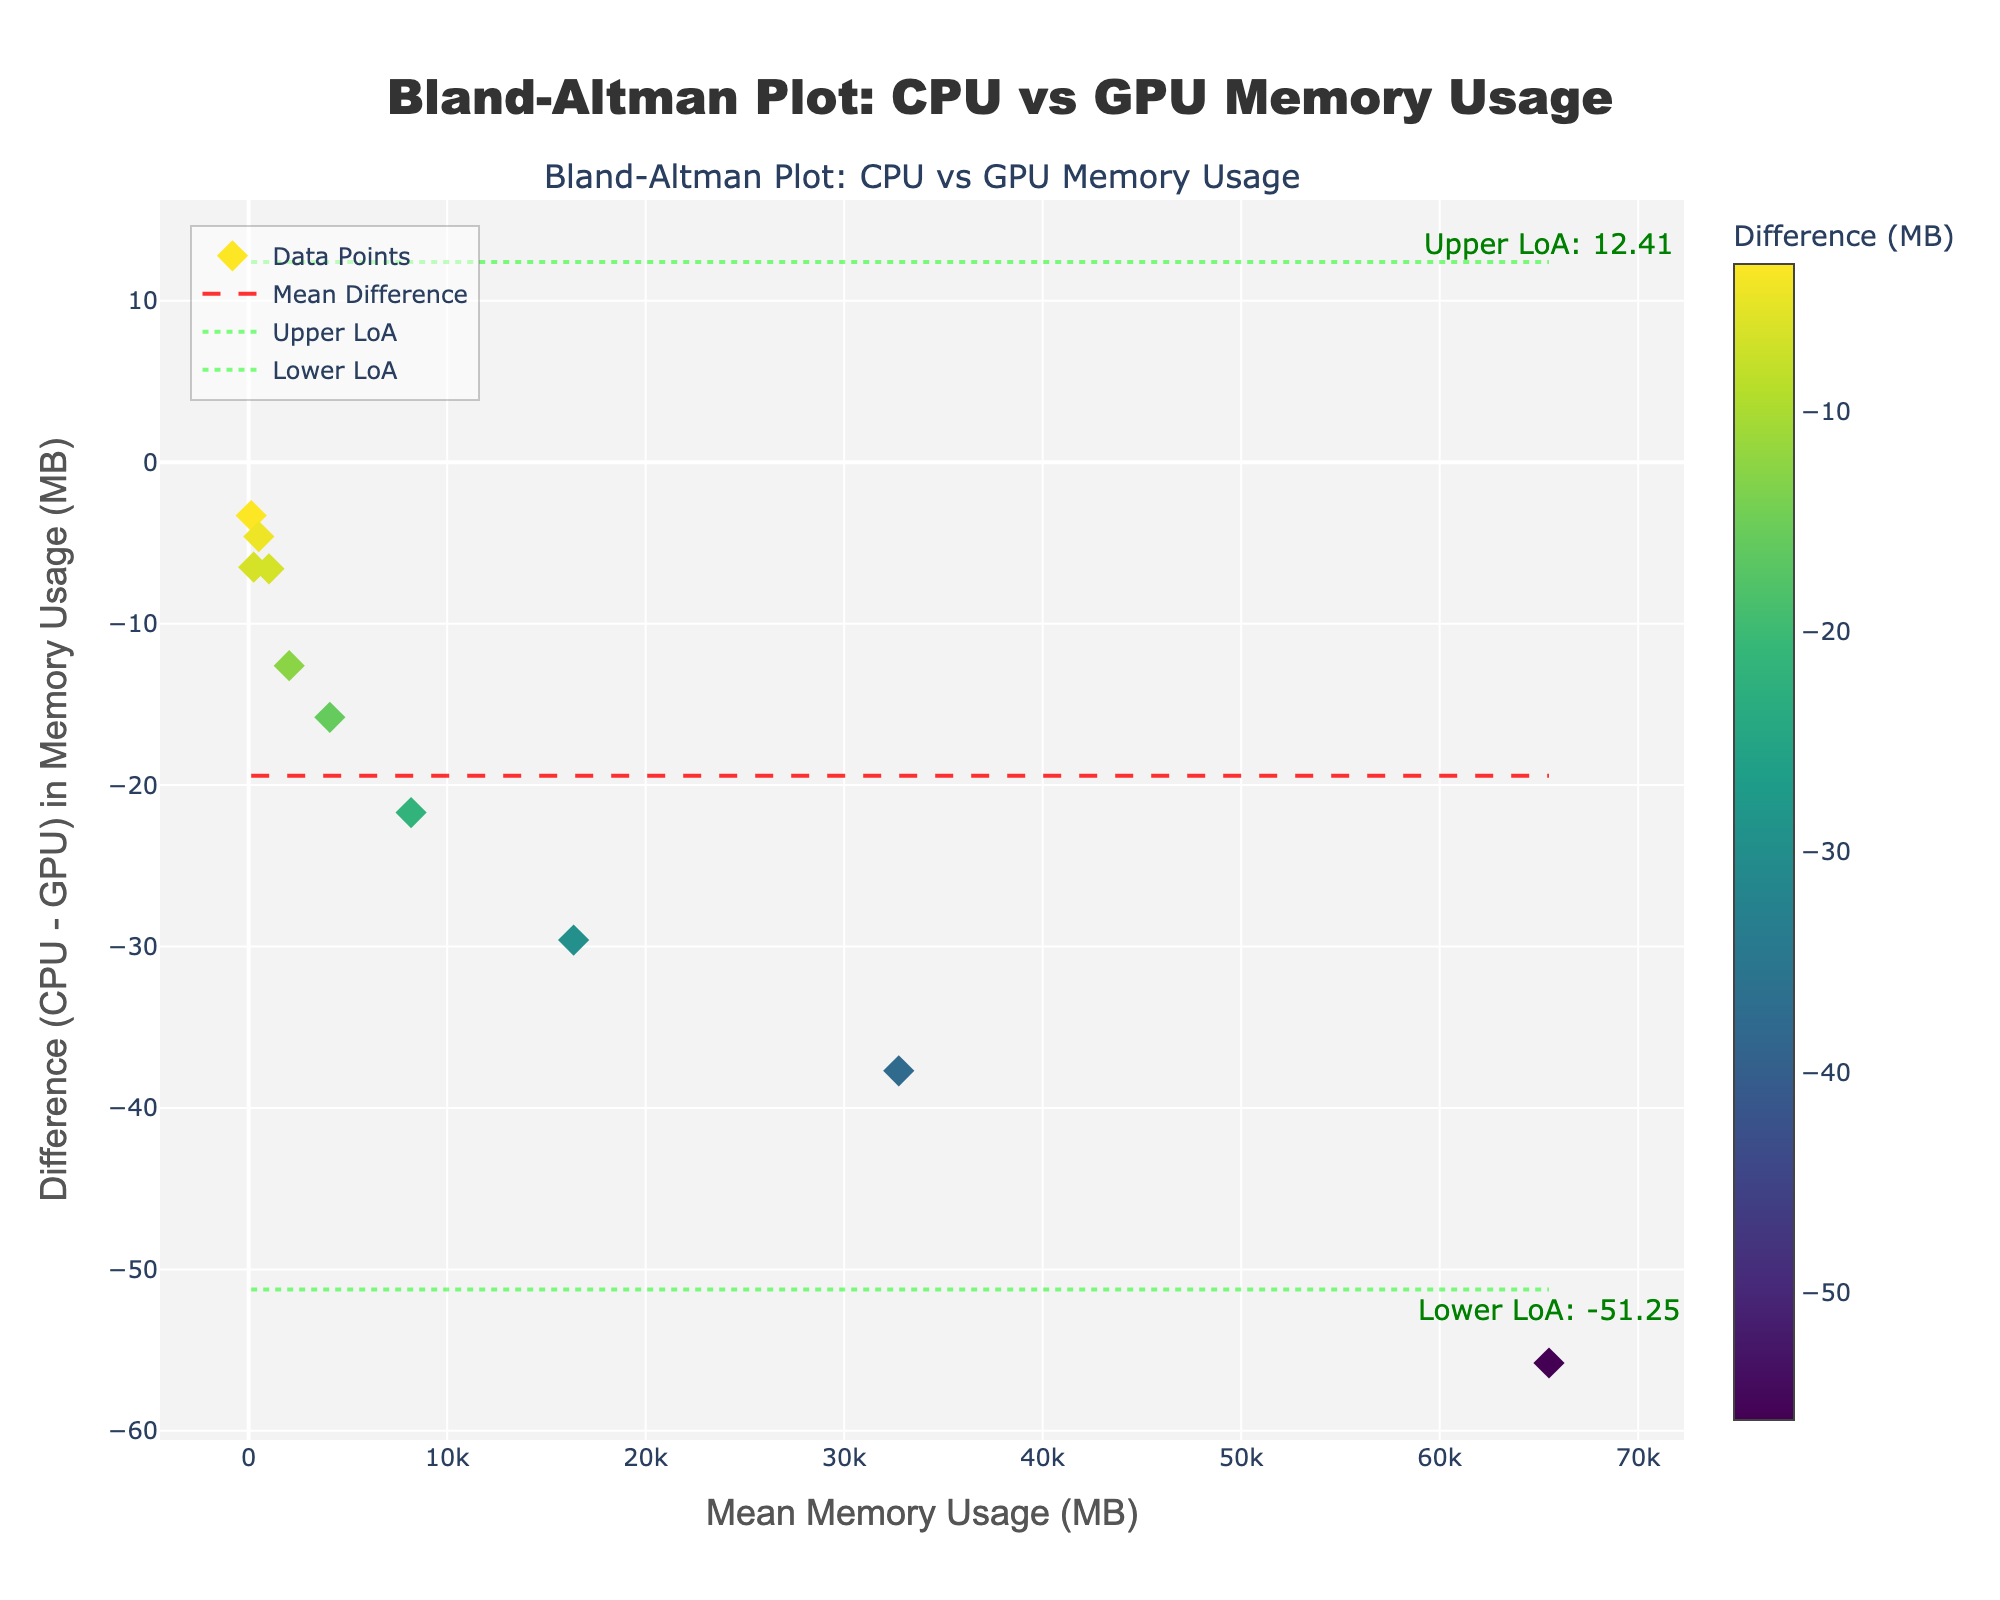What is the title of the Bland-Altman plot? The title is prominently displayed at the top of the figure, informing viewers about the content of the plot.
Answer: Bland-Altman Plot: CPU vs GPU Memory Usage What are the units of the x-axis and y-axis? The x-axis is labeled "Mean Memory Usage (MB)" and the y-axis is labeled "Difference (CPU - GPU) in Memory Usage (MB)", indicating that both axes are measured in megabytes (MB).
Answer: MB How many data points are plotted in the figure? Each row in the provided data represents a single data point plotted in the Bland-Altman plot. Counting the rows gives us the total number of data points.
Answer: 10 What is the color scheme of the data points and what additional visual element does it include? The data points are colored using a 'Viridis' colorscale, with color intensity representing the difference value. There is also a color bar titled "Difference (MB)" indicating these values.
Answer: Viridis What is the range of mean memory usage in the x-axis? The minimum mean memory usage is calculated from the smallest value in 'Mean_Memory_Usage' and the maximum is calculated from the largest value in the same column, ranging from the smallest to the largest mean memory usage values.
Answer: 126.85 to 65508.4 MB What is the mean difference line and its color/style? The mean difference line is a red dashed line that runs horizontally across the plot, representing the mean of all the differences given.
Answer: Red dashed line What are the upper and lower limits of agreement (LoA) and their color/style? The upper and lower LoA are represented by green dotted lines. These lines are calculated as \(\text{mean difference} \pm 1.96 \times \text{standard deviation of the differences}\).
Answer: Green dotted lines Which data point shows the highest difference in memory usage between CPU and GPU? By examining the data points along the y-axis, the highest difference corresponds to the point with the maximum negative value, which is -55.8 MB.
Answer: -55.8 MB What is the mean value of memory usage when the difference is -6.5 MB? This corresponds to the data point where 'Difference' is -6.5 MB. By locating this point in the table, we find the 'Mean_Memory_Usage' value.
Answer: 253.05 MB Are there more data points above or below the mean difference line? By visually assessing the number of data points relative to the red dashed mean difference line in the plot, one can count the points above and below the line to determine the majority.
Answer: Below 